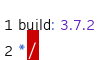<code> <loc_0><loc_0><loc_500><loc_500><_JavaScript_>build: 3.7.2
*/</code> 